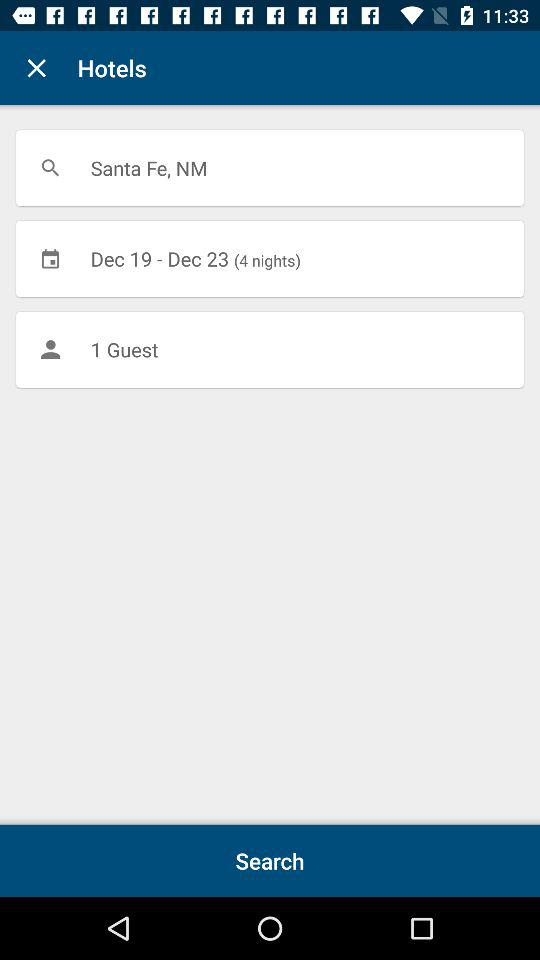For how many nights is the hotel booked? The hotel is booked for 4 nights. 